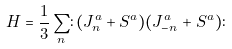<formula> <loc_0><loc_0><loc_500><loc_500>H = \frac { 1 } { 3 } \sum _ { n } \colon ( J ^ { a } _ { n } + S ^ { a } ) ( J ^ { a } _ { - n } + S ^ { a } ) \colon</formula> 